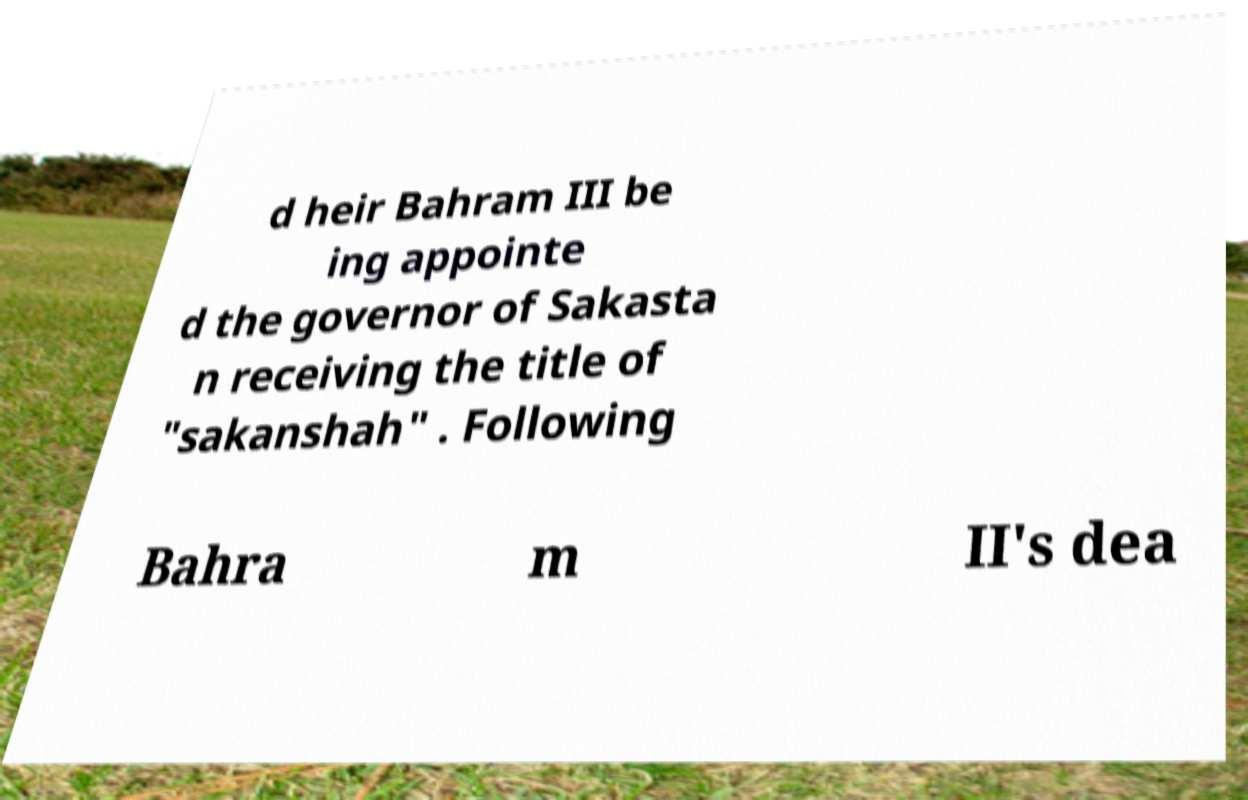For documentation purposes, I need the text within this image transcribed. Could you provide that? d heir Bahram III be ing appointe d the governor of Sakasta n receiving the title of "sakanshah" . Following Bahra m II's dea 